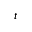<formula> <loc_0><loc_0><loc_500><loc_500>^ { t }</formula> 